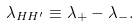Convert formula to latex. <formula><loc_0><loc_0><loc_500><loc_500>\lambda _ { H H ^ { \prime } } \equiv \lambda _ { + } - \lambda _ { - } .</formula> 